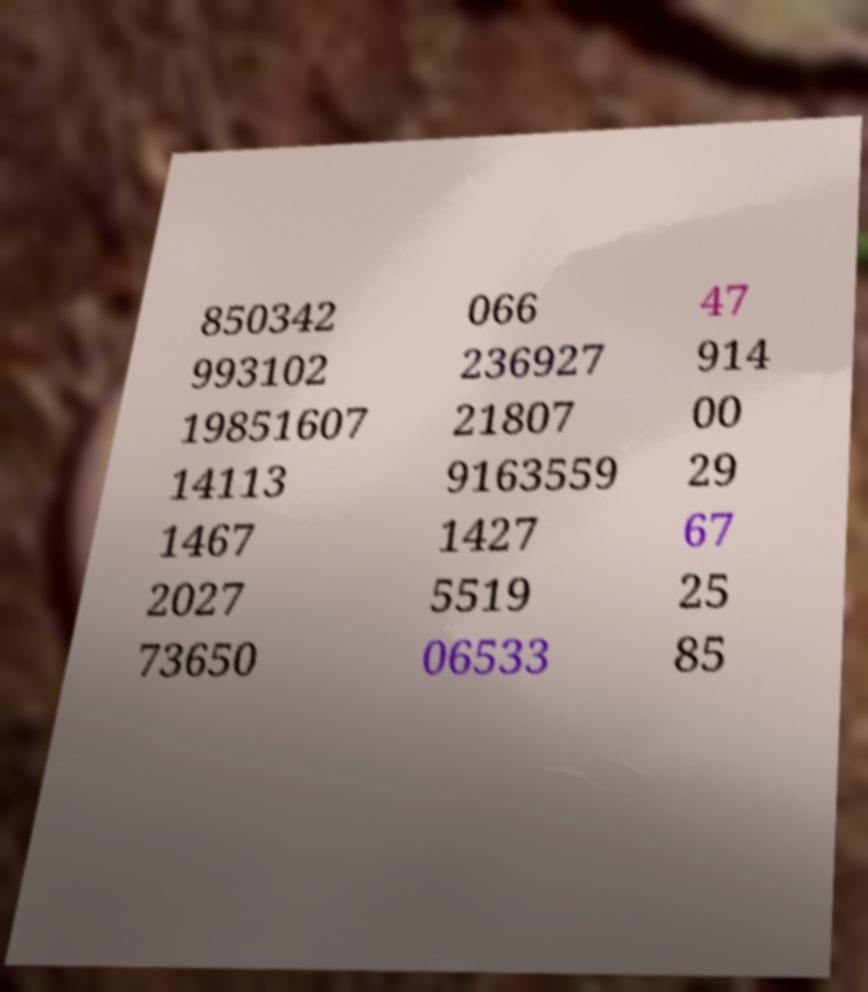I need the written content from this picture converted into text. Can you do that? 850342 993102 19851607 14113 1467 2027 73650 066 236927 21807 9163559 1427 5519 06533 47 914 00 29 67 25 85 